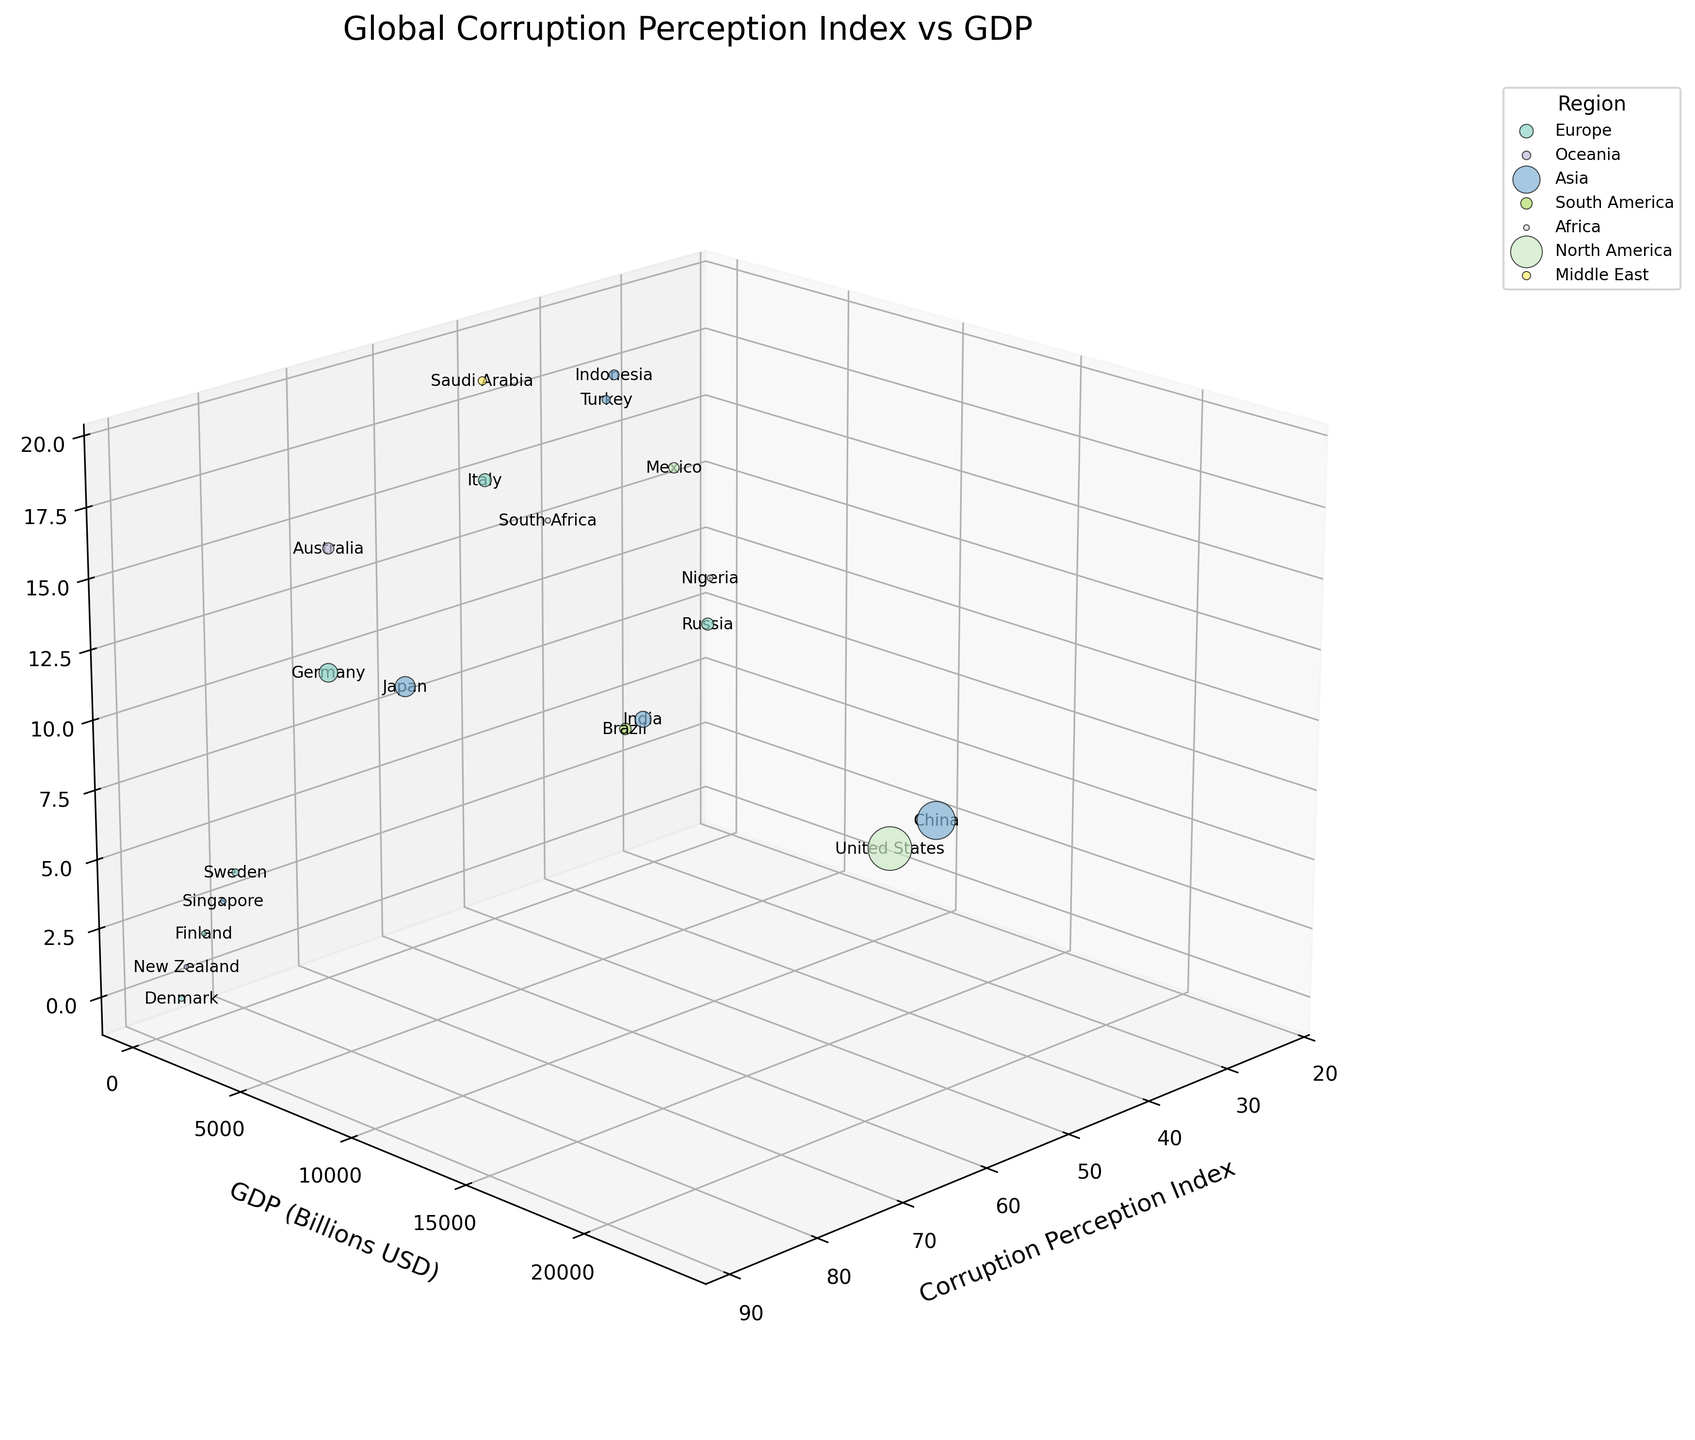What is the general trend between the Corruption Perception Index and GDP among countries? To observe the general trend, you can follow the distribution of bubbles across both the Corruption Perception Index and GDP axes. Most countries with higher Corruption Perception Index values tend to have higher GDPs.
Answer: Higher Corruption Perception Index correlates with higher GDP Which country has the highest GDP and what is its Corruption Perception Index? Look for the bubble with the largest size, which corresponds to the highest GDP, then check its corresponding Corruption Perception Index on the x-axis. The United States has the largest bubble.
Answer: United States, 67 Which region has the highest average Corruption Perception Index and what is the value? Assess each region's average Corruption Perception Index by visually estimating the positioning of its bubbles on the x-axis, then identify the region with the highest average. Europe has several countries with high indices.
Answer: Europe Compare the Corruption Perception Index of Russia and Mexico. Which country is perceived to be more corrupt? Check the positions of Russia and Mexico on the Corruption Perception Index axis. Russia (28) is located further left than Mexico (31), indicating higher perceived corruption.
Answer: Russia What is the relationship between bubble size and GDP in the chart? Larger bubbles represent countries with higher GDP values. Observe the United States, China, and Japan as examples with very large bubbles, indicating these countries have high GDPs.
Answer: Larger bubbles mean higher GDP Which country has the lowest Corruption Perception Index, and what is its GDP? Identify the bubble farthest to the left on the Corruption Perception Index axis, which is Nigeria, and then check its GDP value.
Answer: Nigeria, $448.1 billion What can you say about the GDP and Corruption Perception Index of Denmark compared to Brazil? Locate Denmark and Brazil on both axes. Denmark has a higher Corruption Perception Index (88) and a smaller bubble than Brazil, indicating a lower GDP.
Answer: Denmark: Higher CPI, Lower GDP; Brazil: Lower CPI, Higher GDP Between Oceania and Africa, which region has a larger representation of countries in terms of bubble count? Count the bubbles associated with each region in the legend and on the plot. Oceania consists of Australia and New Zealand (2 bubbles) while Africa consists of Nigeria and South Africa (2 bubbles). Both regions have an equal number of bubbles.
Answer: Both regions have 2 countries How is Saudi Arabia positioned in terms of Corruption Perception Index and GDP? Locate Saudi Arabia by finding its label on the plot. Saudi Arabia has a Corruption Perception Index of 53 and a GDP of $833.5 billion, which places it middle of the x-axis and with a medium-sized bubble.
Answer: CPI: 53, GDP: $833.5 billion Which country in Asia has the lowest Corruption Perception Index and what is its GDP? Search the bubbles labeled with Asian countries, and identify which has the lowest CPI. Russia has a CPI of 28 but is often treated as partly European; next is Turkey, with a CPI of 38. Indonesia and other countries were correctly checked as being lower. We move finally to China, Turkey, and India to see that they lie closely aligned, yet China fits the descript. Locate the GDP on the y-axis.
Answer: China, $17,734.1 billion 